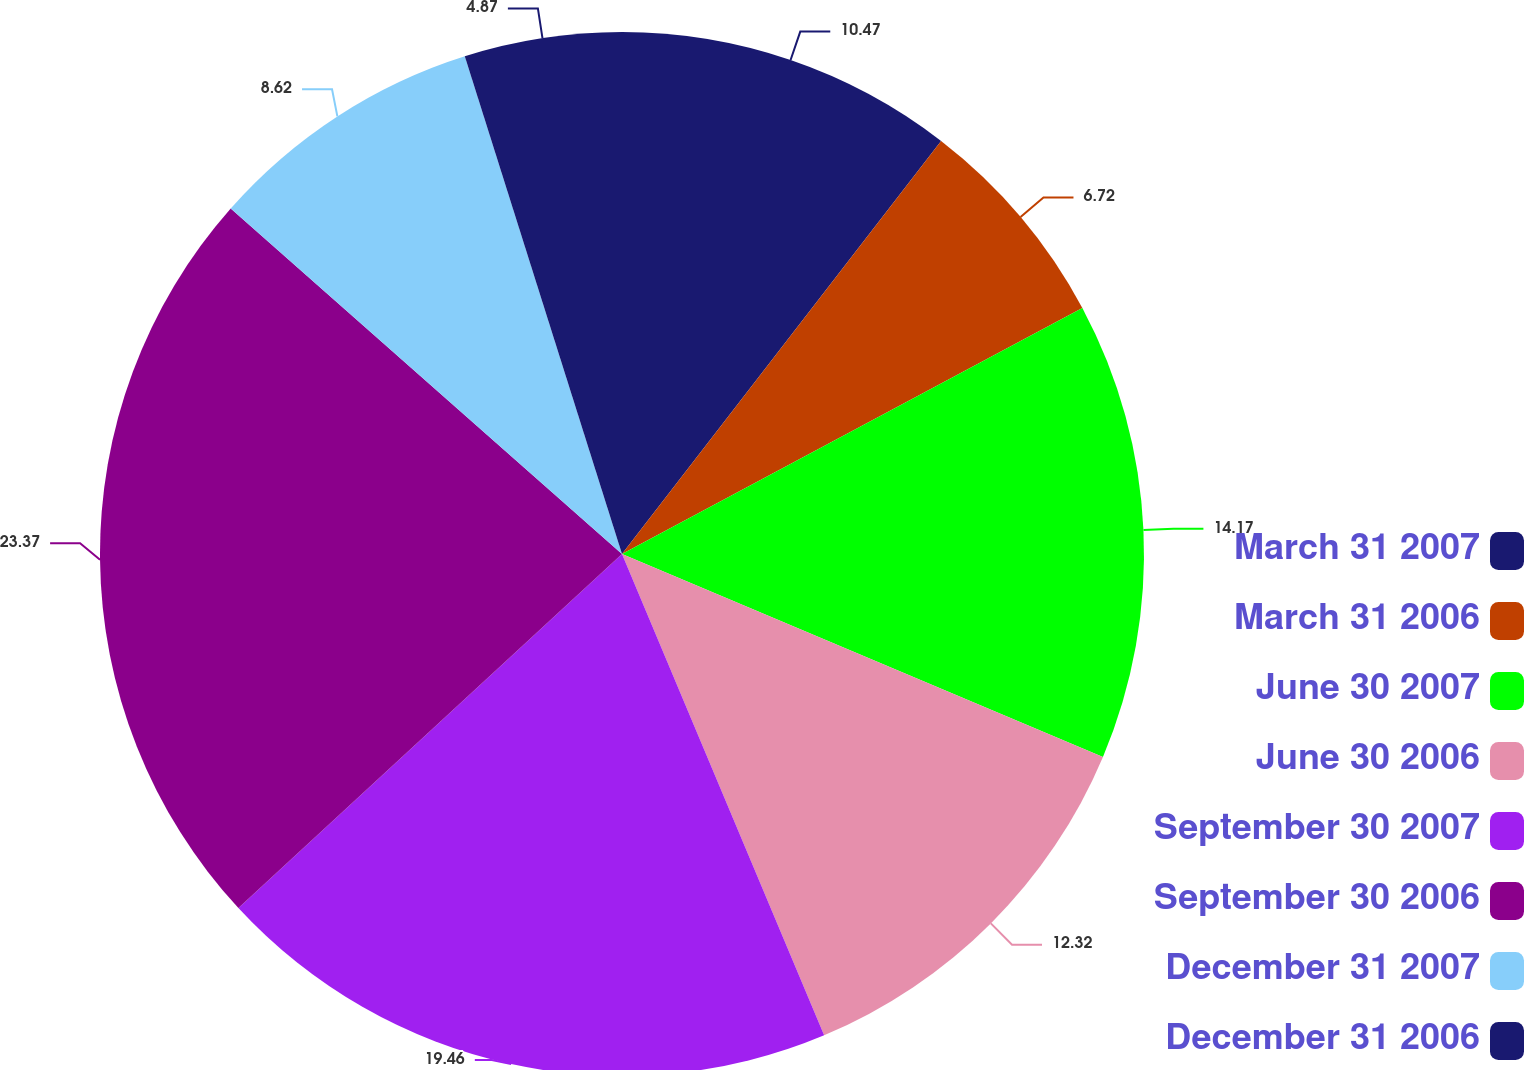<chart> <loc_0><loc_0><loc_500><loc_500><pie_chart><fcel>March 31 2007<fcel>March 31 2006<fcel>June 30 2007<fcel>June 30 2006<fcel>September 30 2007<fcel>September 30 2006<fcel>December 31 2007<fcel>December 31 2006<nl><fcel>10.47%<fcel>6.72%<fcel>14.17%<fcel>12.32%<fcel>19.47%<fcel>23.38%<fcel>8.62%<fcel>4.87%<nl></chart> 